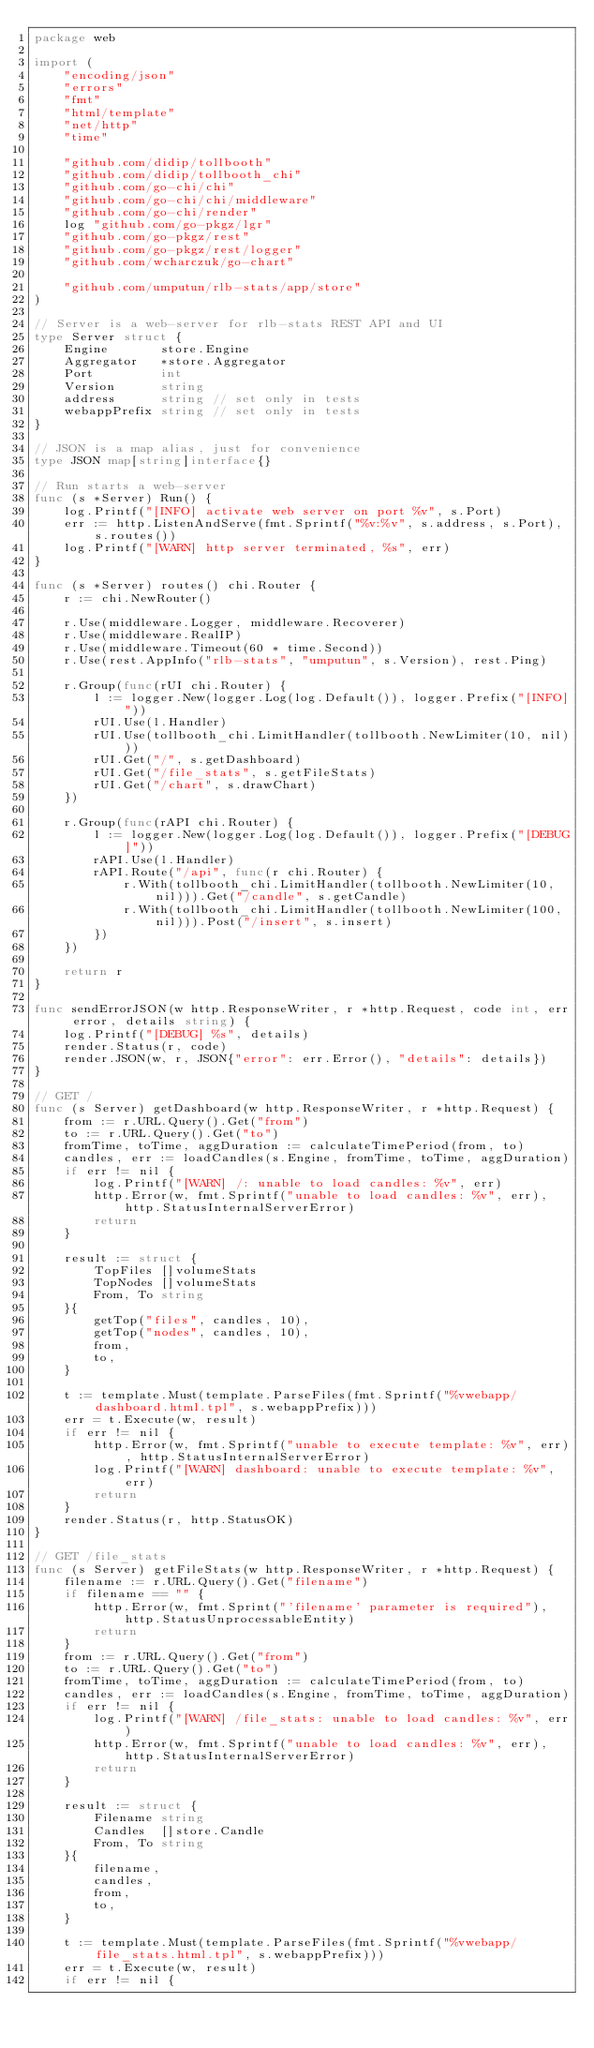<code> <loc_0><loc_0><loc_500><loc_500><_Go_>package web

import (
	"encoding/json"
	"errors"
	"fmt"
	"html/template"
	"net/http"
	"time"

	"github.com/didip/tollbooth"
	"github.com/didip/tollbooth_chi"
	"github.com/go-chi/chi"
	"github.com/go-chi/chi/middleware"
	"github.com/go-chi/render"
	log "github.com/go-pkgz/lgr"
	"github.com/go-pkgz/rest"
	"github.com/go-pkgz/rest/logger"
	"github.com/wcharczuk/go-chart"

	"github.com/umputun/rlb-stats/app/store"
)

// Server is a web-server for rlb-stats REST API and UI
type Server struct {
	Engine       store.Engine
	Aggregator   *store.Aggregator
	Port         int
	Version      string
	address      string // set only in tests
	webappPrefix string // set only in tests
}

// JSON is a map alias, just for convenience
type JSON map[string]interface{}

// Run starts a web-server
func (s *Server) Run() {
	log.Printf("[INFO] activate web server on port %v", s.Port)
	err := http.ListenAndServe(fmt.Sprintf("%v:%v", s.address, s.Port), s.routes())
	log.Printf("[WARN] http server terminated, %s", err)
}

func (s *Server) routes() chi.Router {
	r := chi.NewRouter()

	r.Use(middleware.Logger, middleware.Recoverer)
	r.Use(middleware.RealIP)
	r.Use(middleware.Timeout(60 * time.Second))
	r.Use(rest.AppInfo("rlb-stats", "umputun", s.Version), rest.Ping)

	r.Group(func(rUI chi.Router) {
		l := logger.New(logger.Log(log.Default()), logger.Prefix("[INFO]"))
		rUI.Use(l.Handler)
		rUI.Use(tollbooth_chi.LimitHandler(tollbooth.NewLimiter(10, nil)))
		rUI.Get("/", s.getDashboard)
		rUI.Get("/file_stats", s.getFileStats)
		rUI.Get("/chart", s.drawChart)
	})

	r.Group(func(rAPI chi.Router) {
		l := logger.New(logger.Log(log.Default()), logger.Prefix("[DEBUG]"))
		rAPI.Use(l.Handler)
		rAPI.Route("/api", func(r chi.Router) {
			r.With(tollbooth_chi.LimitHandler(tollbooth.NewLimiter(10, nil))).Get("/candle", s.getCandle)
			r.With(tollbooth_chi.LimitHandler(tollbooth.NewLimiter(100, nil))).Post("/insert", s.insert)
		})
	})

	return r
}

func sendErrorJSON(w http.ResponseWriter, r *http.Request, code int, err error, details string) {
	log.Printf("[DEBUG] %s", details)
	render.Status(r, code)
	render.JSON(w, r, JSON{"error": err.Error(), "details": details})
}

// GET /
func (s Server) getDashboard(w http.ResponseWriter, r *http.Request) {
	from := r.URL.Query().Get("from")
	to := r.URL.Query().Get("to")
	fromTime, toTime, aggDuration := calculateTimePeriod(from, to)
	candles, err := loadCandles(s.Engine, fromTime, toTime, aggDuration)
	if err != nil {
		log.Printf("[WARN] /: unable to load candles: %v", err)
		http.Error(w, fmt.Sprintf("unable to load candles: %v", err), http.StatusInternalServerError)
		return
	}

	result := struct {
		TopFiles []volumeStats
		TopNodes []volumeStats
		From, To string
	}{
		getTop("files", candles, 10),
		getTop("nodes", candles, 10),
		from,
		to,
	}

	t := template.Must(template.ParseFiles(fmt.Sprintf("%vwebapp/dashboard.html.tpl", s.webappPrefix)))
	err = t.Execute(w, result)
	if err != nil {
		http.Error(w, fmt.Sprintf("unable to execute template: %v", err), http.StatusInternalServerError)
		log.Printf("[WARN] dashboard: unable to execute template: %v", err)
		return
	}
	render.Status(r, http.StatusOK)
}

// GET /file_stats
func (s Server) getFileStats(w http.ResponseWriter, r *http.Request) {
	filename := r.URL.Query().Get("filename")
	if filename == "" {
		http.Error(w, fmt.Sprint("'filename' parameter is required"), http.StatusUnprocessableEntity)
		return
	}
	from := r.URL.Query().Get("from")
	to := r.URL.Query().Get("to")
	fromTime, toTime, aggDuration := calculateTimePeriod(from, to)
	candles, err := loadCandles(s.Engine, fromTime, toTime, aggDuration)
	if err != nil {
		log.Printf("[WARN] /file_stats: unable to load candles: %v", err)
		http.Error(w, fmt.Sprintf("unable to load candles: %v", err), http.StatusInternalServerError)
		return
	}

	result := struct {
		Filename string
		Candles  []store.Candle
		From, To string
	}{
		filename,
		candles,
		from,
		to,
	}

	t := template.Must(template.ParseFiles(fmt.Sprintf("%vwebapp/file_stats.html.tpl", s.webappPrefix)))
	err = t.Execute(w, result)
	if err != nil {</code> 